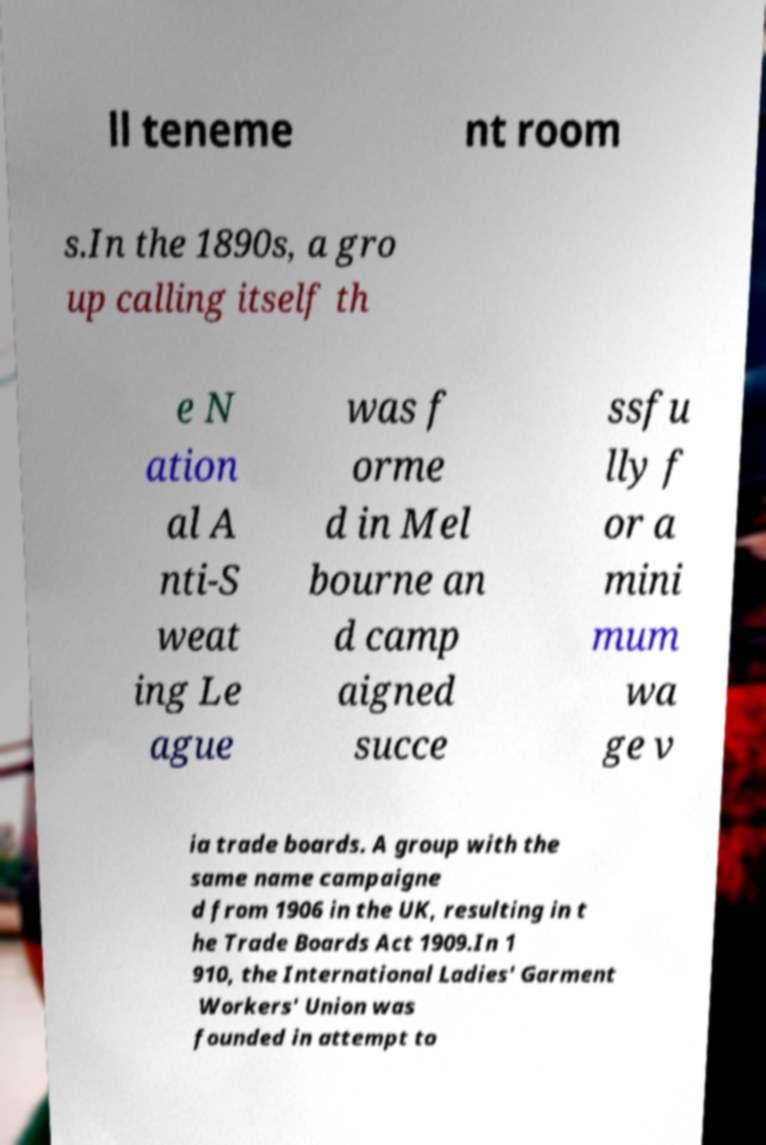Please read and relay the text visible in this image. What does it say? ll teneme nt room s.In the 1890s, a gro up calling itself th e N ation al A nti-S weat ing Le ague was f orme d in Mel bourne an d camp aigned succe ssfu lly f or a mini mum wa ge v ia trade boards. A group with the same name campaigne d from 1906 in the UK, resulting in t he Trade Boards Act 1909.In 1 910, the International Ladies' Garment Workers' Union was founded in attempt to 